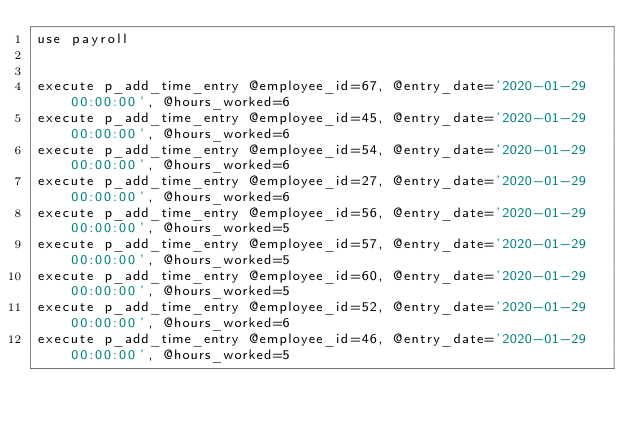Convert code to text. <code><loc_0><loc_0><loc_500><loc_500><_SQL_>use payroll


execute p_add_time_entry @employee_id=67, @entry_date='2020-01-29 00:00:00', @hours_worked=6
execute p_add_time_entry @employee_id=45, @entry_date='2020-01-29 00:00:00', @hours_worked=6
execute p_add_time_entry @employee_id=54, @entry_date='2020-01-29 00:00:00', @hours_worked=6
execute p_add_time_entry @employee_id=27, @entry_date='2020-01-29 00:00:00', @hours_worked=6
execute p_add_time_entry @employee_id=56, @entry_date='2020-01-29 00:00:00', @hours_worked=5
execute p_add_time_entry @employee_id=57, @entry_date='2020-01-29 00:00:00', @hours_worked=5
execute p_add_time_entry @employee_id=60, @entry_date='2020-01-29 00:00:00', @hours_worked=5
execute p_add_time_entry @employee_id=52, @entry_date='2020-01-29 00:00:00', @hours_worked=6
execute p_add_time_entry @employee_id=46, @entry_date='2020-01-29 00:00:00', @hours_worked=5

</code> 